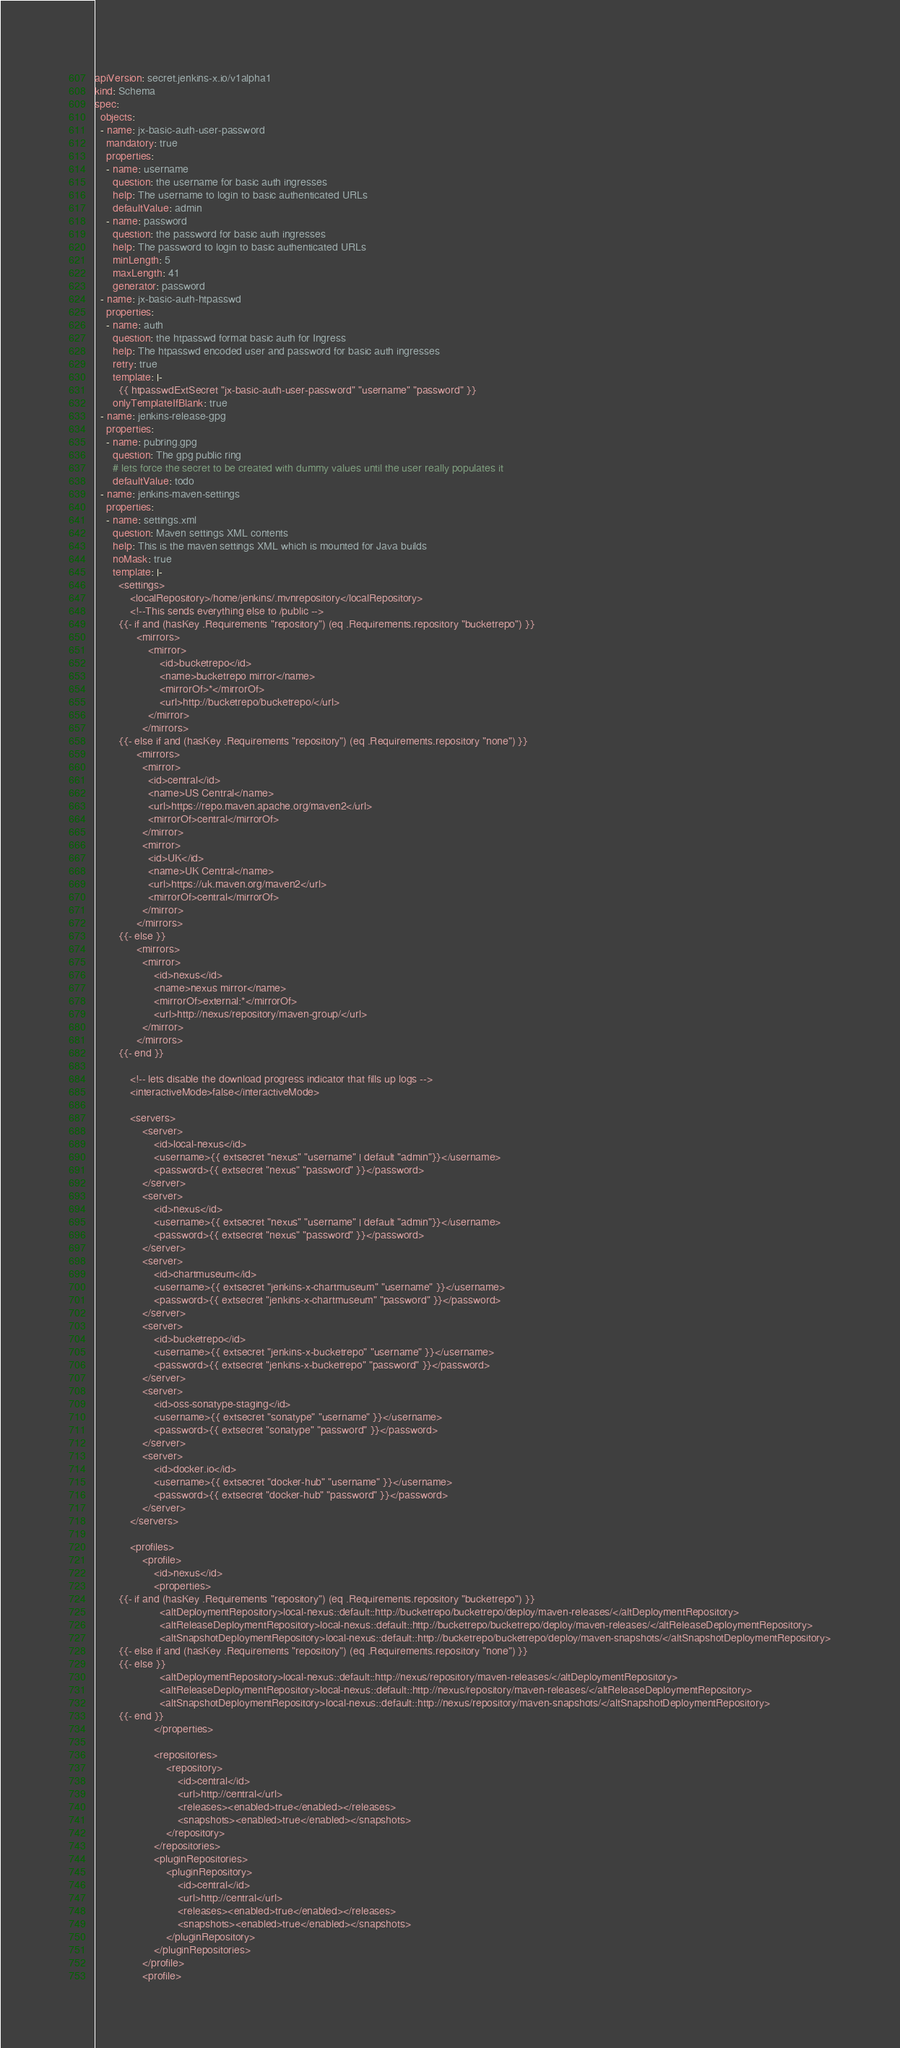Convert code to text. <code><loc_0><loc_0><loc_500><loc_500><_YAML_>apiVersion: secret.jenkins-x.io/v1alpha1
kind: Schema
spec:
  objects:
  - name: jx-basic-auth-user-password
    mandatory: true
    properties:
    - name: username
      question: the username for basic auth ingresses
      help: The username to login to basic authenticated URLs
      defaultValue: admin
    - name: password
      question: the password for basic auth ingresses
      help: The password to login to basic authenticated URLs
      minLength: 5
      maxLength: 41
      generator: password
  - name: jx-basic-auth-htpasswd
    properties:
    - name: auth
      question: the htpasswd format basic auth for Ingress
      help: The htpasswd encoded user and password for basic auth ingresses
      retry: true
      template: |-
        {{ htpasswdExtSecret "jx-basic-auth-user-password" "username" "password" }}
      onlyTemplateIfBlank: true
  - name: jenkins-release-gpg
    properties:
    - name: pubring.gpg
      question: The gpg public ring
      # lets force the secret to be created with dummy values until the user really populates it
      defaultValue: todo
  - name: jenkins-maven-settings
    properties:
    - name: settings.xml
      question: Maven settings XML contents
      help: This is the maven settings XML which is mounted for Java builds
      noMask: true
      template: |-
        <settings>
            <localRepository>/home/jenkins/.mvnrepository</localRepository>
            <!--This sends everything else to /public -->
        {{- if and (hasKey .Requirements "repository") (eq .Requirements.repository "bucketrepo") }}
              <mirrors>
                  <mirror>
                      <id>bucketrepo</id>
                      <name>bucketrepo mirror</name>
                      <mirrorOf>*</mirrorOf>
                      <url>http://bucketrepo/bucketrepo/</url>
                  </mirror>
                </mirrors>
        {{- else if and (hasKey .Requirements "repository") (eq .Requirements.repository "none") }}
              <mirrors>
                <mirror>
                  <id>central</id>
                  <name>US Central</name>
                  <url>https://repo.maven.apache.org/maven2</url>
                  <mirrorOf>central</mirrorOf>
                </mirror>
                <mirror>
                  <id>UK</id>
                  <name>UK Central</name>
                  <url>https://uk.maven.org/maven2</url>
                  <mirrorOf>central</mirrorOf>
                </mirror>
              </mirrors>
        {{- else }}
              <mirrors>
                <mirror>
                    <id>nexus</id>
                    <name>nexus mirror</name>
                    <mirrorOf>external:*</mirrorOf>
                    <url>http://nexus/repository/maven-group/</url>
                </mirror>
              </mirrors>
        {{- end }}

            <!-- lets disable the download progress indicator that fills up logs -->
            <interactiveMode>false</interactiveMode>

            <servers>
                <server>
                    <id>local-nexus</id>
                    <username>{{ extsecret "nexus" "username" | default "admin"}}</username>
                    <password>{{ extsecret "nexus" "password" }}</password>
                </server>
                <server>
                    <id>nexus</id>
                    <username>{{ extsecret "nexus" "username" | default "admin"}}</username>
                    <password>{{ extsecret "nexus" "password" }}</password>
                </server>
                <server>
                    <id>chartmuseum</id>
                    <username>{{ extsecret "jenkins-x-chartmuseum" "username" }}</username>
                    <password>{{ extsecret "jenkins-x-chartmuseum" "password" }}</password>
                </server>
                <server>
                    <id>bucketrepo</id>
                    <username>{{ extsecret "jenkins-x-bucketrepo" "username" }}</username>
                    <password>{{ extsecret "jenkins-x-bucketrepo" "password" }}</password>
                </server>
                <server>
                    <id>oss-sonatype-staging</id>
                    <username>{{ extsecret "sonatype" "username" }}</username>
                    <password>{{ extsecret "sonatype" "password" }}</password>
                </server>
                <server>
                    <id>docker.io</id>
                    <username>{{ extsecret "docker-hub" "username" }}</username>
                    <password>{{ extsecret "docker-hub" "password" }}</password>
                </server>
            </servers>

            <profiles>
                <profile>
                    <id>nexus</id>
                    <properties>
        {{- if and (hasKey .Requirements "repository") (eq .Requirements.repository "bucketrepo") }}
                      <altDeploymentRepository>local-nexus::default::http://bucketrepo/bucketrepo/deploy/maven-releases/</altDeploymentRepository>
                      <altReleaseDeploymentRepository>local-nexus::default::http://bucketrepo/bucketrepo/deploy/maven-releases/</altReleaseDeploymentRepository>
                      <altSnapshotDeploymentRepository>local-nexus::default::http://bucketrepo/bucketrepo/deploy/maven-snapshots/</altSnapshotDeploymentRepository>
        {{- else if and (hasKey .Requirements "repository") (eq .Requirements.repository "none") }}
        {{- else }}
                      <altDeploymentRepository>local-nexus::default::http://nexus/repository/maven-releases/</altDeploymentRepository>
                      <altReleaseDeploymentRepository>local-nexus::default::http://nexus/repository/maven-releases/</altReleaseDeploymentRepository>
                      <altSnapshotDeploymentRepository>local-nexus::default::http://nexus/repository/maven-snapshots/</altSnapshotDeploymentRepository>
        {{- end }}
                    </properties>

                    <repositories>
                        <repository>
                            <id>central</id>
                            <url>http://central</url>
                            <releases><enabled>true</enabled></releases>
                            <snapshots><enabled>true</enabled></snapshots>
                        </repository>
                    </repositories>
                    <pluginRepositories>
                        <pluginRepository>
                            <id>central</id>
                            <url>http://central</url>
                            <releases><enabled>true</enabled></releases>
                            <snapshots><enabled>true</enabled></snapshots>
                        </pluginRepository>
                    </pluginRepositories>
                </profile>
                <profile></code> 